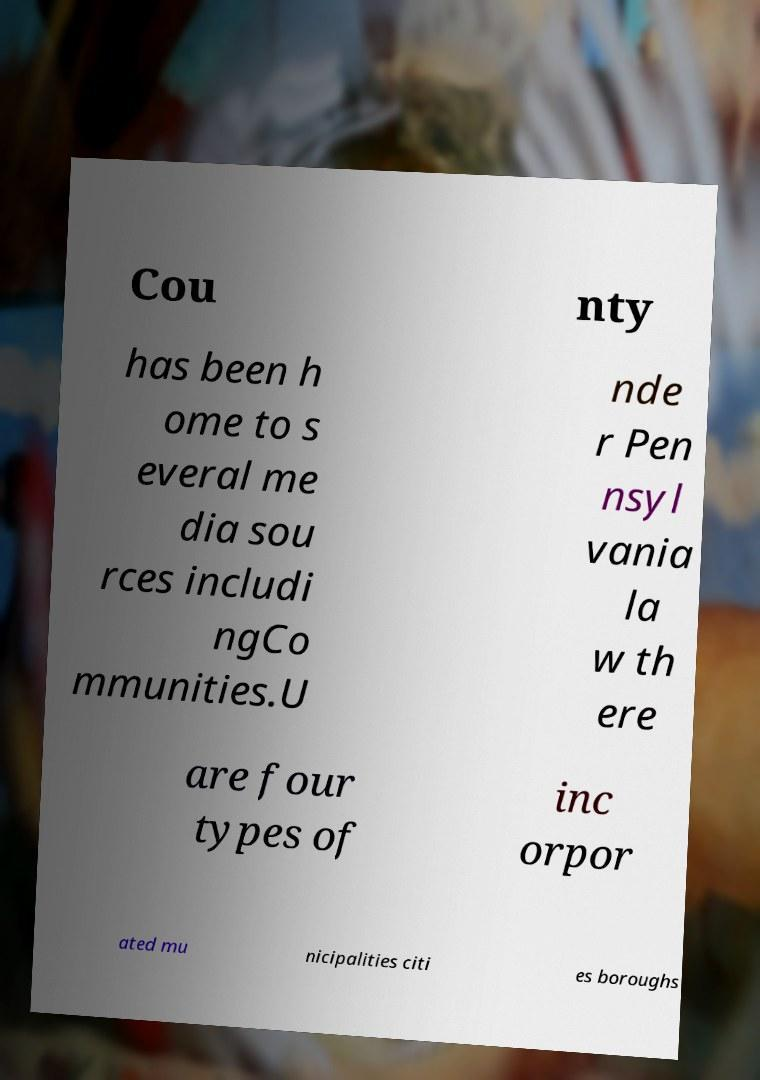What messages or text are displayed in this image? I need them in a readable, typed format. Cou nty has been h ome to s everal me dia sou rces includi ngCo mmunities.U nde r Pen nsyl vania la w th ere are four types of inc orpor ated mu nicipalities citi es boroughs 